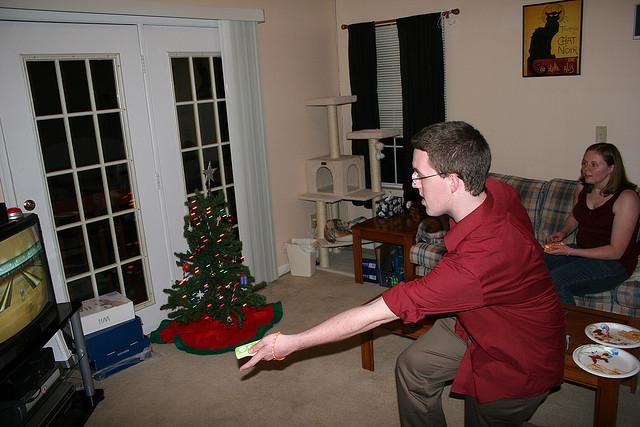What kind of game is the man playing?

Choices:
A) building
B) bowling
C) shooting
D) dancing bowling 